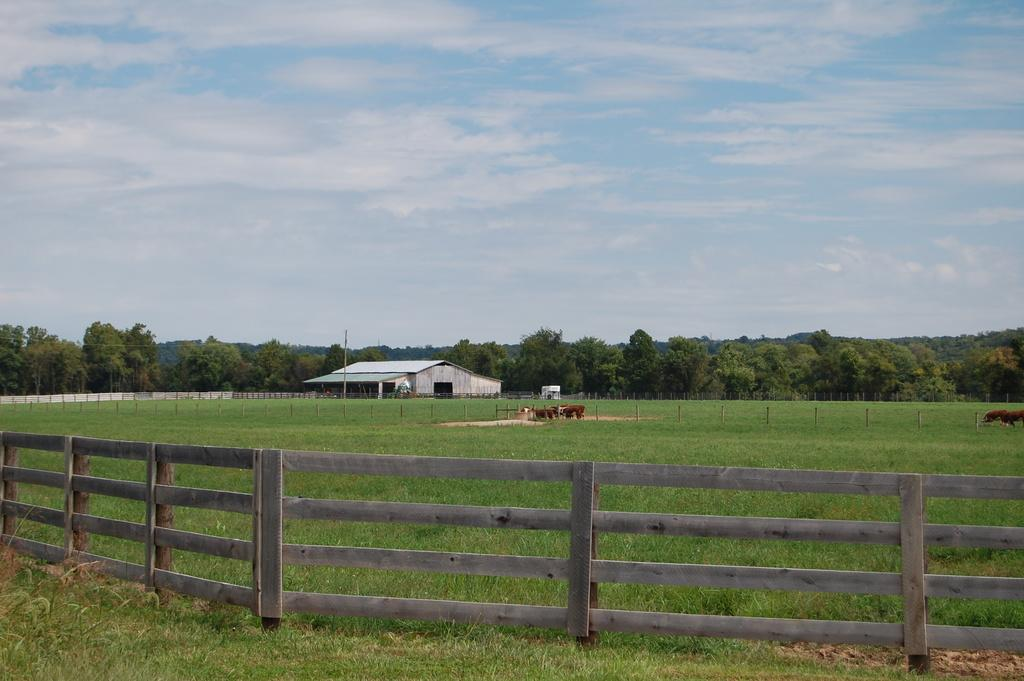What can be seen in the sky in the background of the image? There are clouds in the sky in the background of the image. What other elements are present in the background of the image? There are trees and a shelter in the background of the image. What type of animals are present in the field in the image? Animals are present in the field in the image, but the specific type of animals is not mentioned in the facts. What kind of structures can be seen in the image? There are wooden railings and poles in the image. What is the color of the grass in the image? Green grass is visible in the image. What type of company is conducting business in the image? There is no company or business activity present in the image. How many buckets are visible in the image? There is no mention of buckets in the provided facts, so it cannot be determined how many, if any, are visible in the image. 